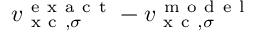Convert formula to latex. <formula><loc_0><loc_0><loc_500><loc_500>v _ { x c , \sigma } ^ { e x a c t } - v _ { x c , \sigma } ^ { m o d e l }</formula> 